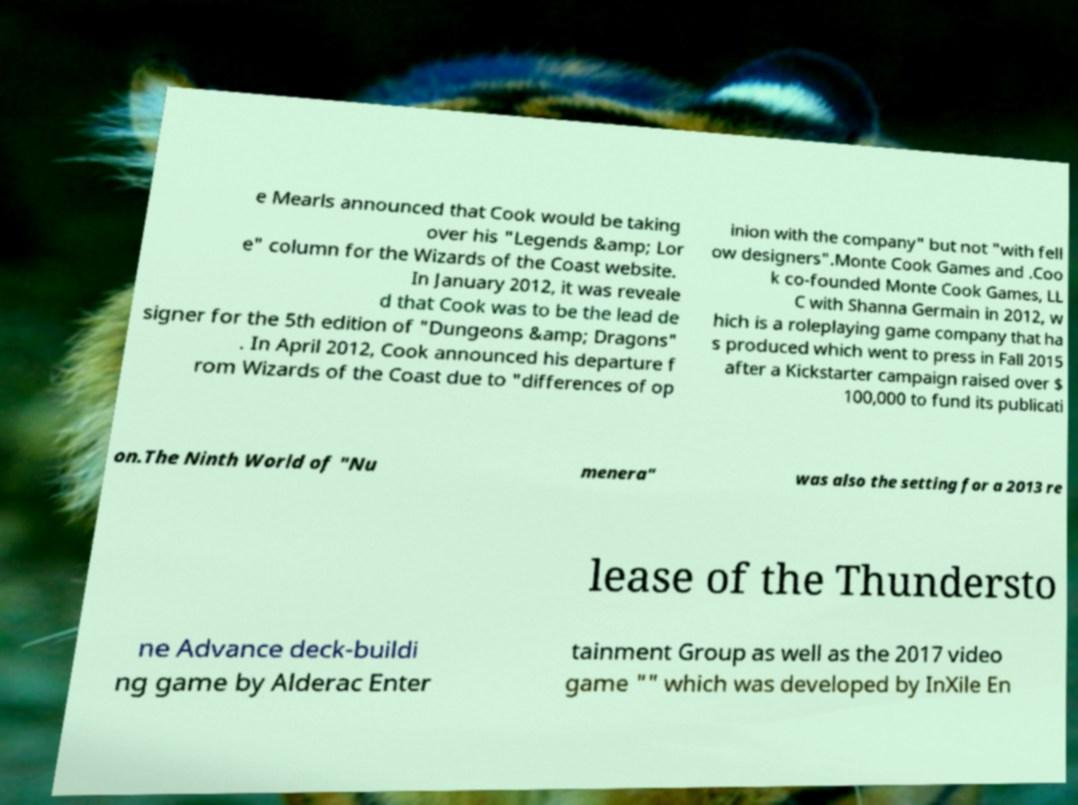Please read and relay the text visible in this image. What does it say? e Mearls announced that Cook would be taking over his "Legends &amp; Lor e" column for the Wizards of the Coast website. In January 2012, it was reveale d that Cook was to be the lead de signer for the 5th edition of "Dungeons &amp; Dragons" . In April 2012, Cook announced his departure f rom Wizards of the Coast due to "differences of op inion with the company" but not "with fell ow designers".Monte Cook Games and .Coo k co-founded Monte Cook Games, LL C with Shanna Germain in 2012, w hich is a roleplaying game company that ha s produced which went to press in Fall 2015 after a Kickstarter campaign raised over $ 100,000 to fund its publicati on.The Ninth World of "Nu menera" was also the setting for a 2013 re lease of the Thundersto ne Advance deck-buildi ng game by Alderac Enter tainment Group as well as the 2017 video game "" which was developed by InXile En 